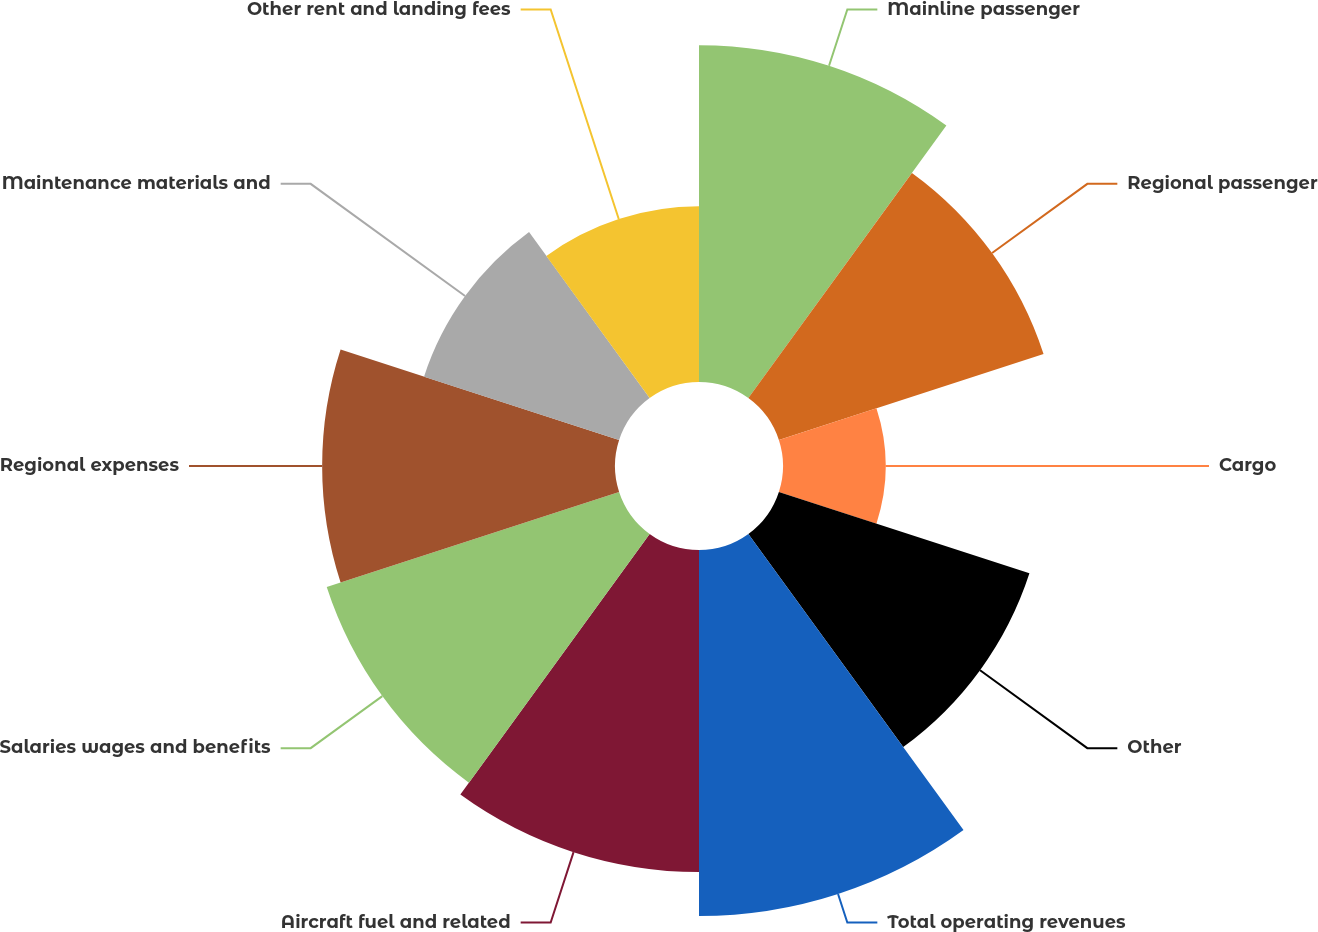Convert chart. <chart><loc_0><loc_0><loc_500><loc_500><pie_chart><fcel>Mainline passenger<fcel>Regional passenger<fcel>Cargo<fcel>Other<fcel>Total operating revenues<fcel>Aircraft fuel and related<fcel>Salaries wages and benefits<fcel>Regional expenses<fcel>Maintenance materials and<fcel>Other rent and landing fees<nl><fcel>12.71%<fcel>10.5%<fcel>3.87%<fcel>9.94%<fcel>13.81%<fcel>12.15%<fcel>11.6%<fcel>11.05%<fcel>7.74%<fcel>6.63%<nl></chart> 